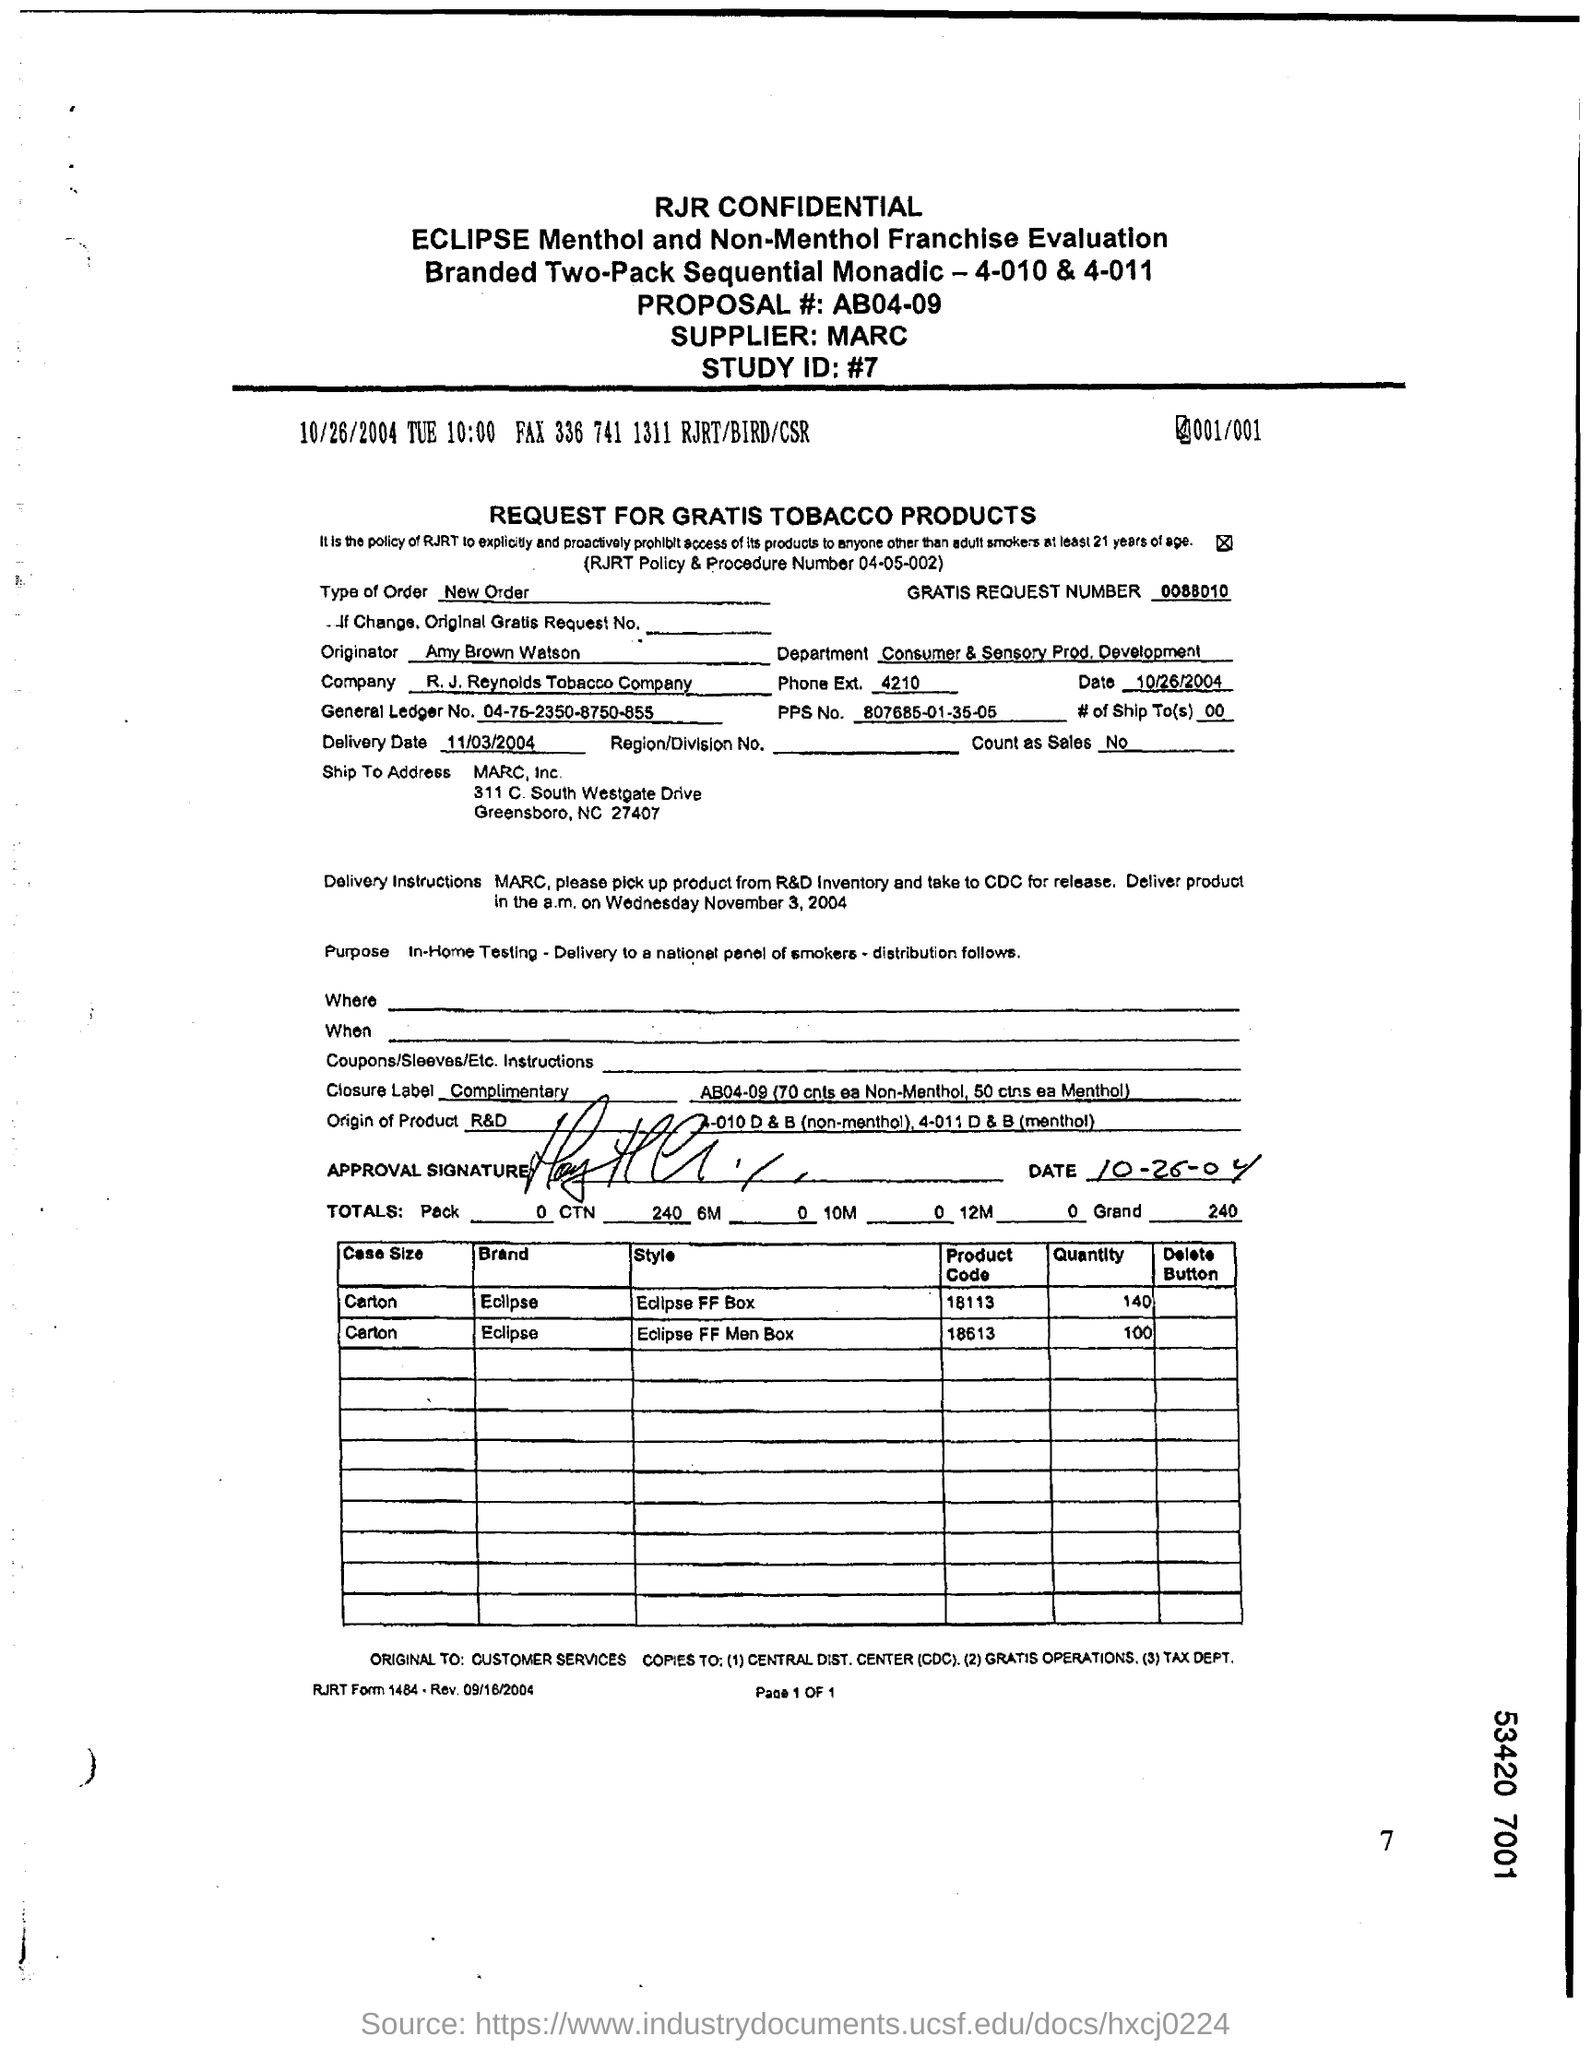Mention a couple of crucial points in this snapshot. The supplier is MARC. The Proposal # is AB04-09. The Department is Consumer & Sensory Prod. Development. The type of order is a new order. What is the Study ID?" is a question. The number "#7" is following it. 